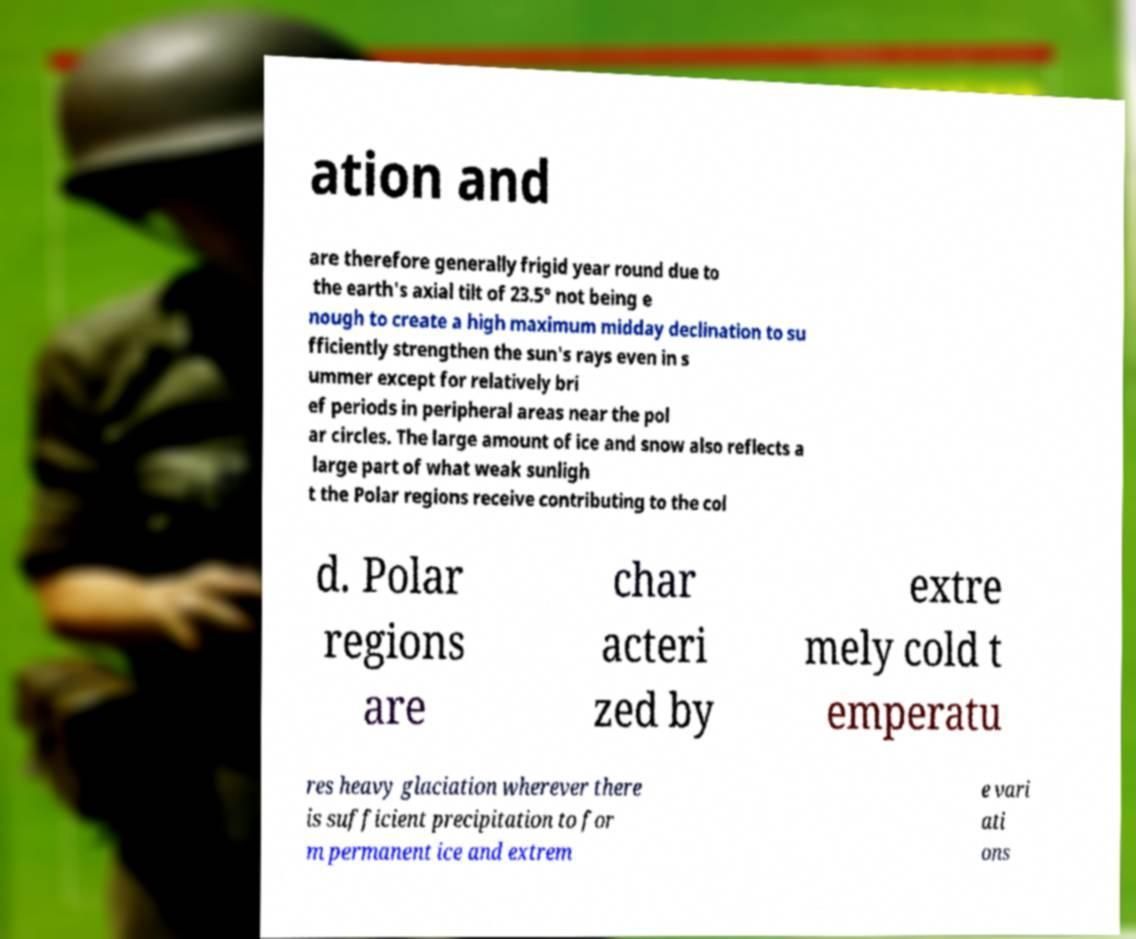For documentation purposes, I need the text within this image transcribed. Could you provide that? ation and are therefore generally frigid year round due to the earth's axial tilt of 23.5° not being e nough to create a high maximum midday declination to su fficiently strengthen the sun's rays even in s ummer except for relatively bri ef periods in peripheral areas near the pol ar circles. The large amount of ice and snow also reflects a large part of what weak sunligh t the Polar regions receive contributing to the col d. Polar regions are char acteri zed by extre mely cold t emperatu res heavy glaciation wherever there is sufficient precipitation to for m permanent ice and extrem e vari ati ons 